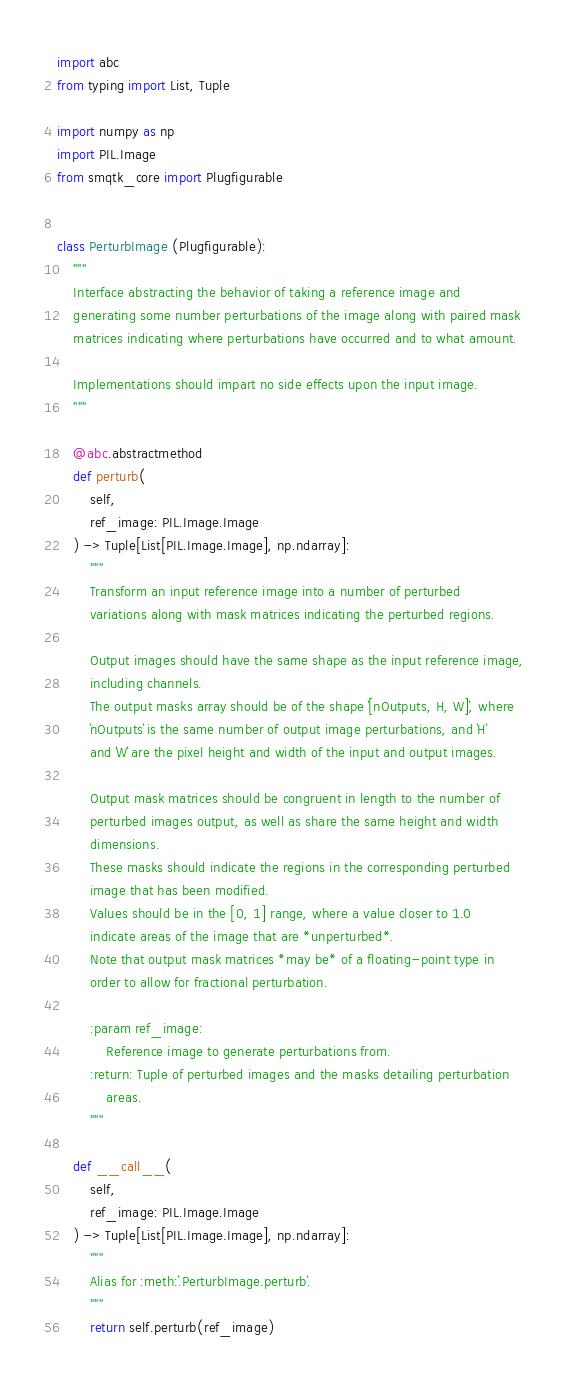<code> <loc_0><loc_0><loc_500><loc_500><_Python_>import abc
from typing import List, Tuple

import numpy as np
import PIL.Image
from smqtk_core import Plugfigurable


class PerturbImage (Plugfigurable):
    """
    Interface abstracting the behavior of taking a reference image and
    generating some number perturbations of the image along with paired mask
    matrices indicating where perturbations have occurred and to what amount.

    Implementations should impart no side effects upon the input image.
    """

    @abc.abstractmethod
    def perturb(
        self,
        ref_image: PIL.Image.Image
    ) -> Tuple[List[PIL.Image.Image], np.ndarray]:
        """
        Transform an input reference image into a number of perturbed
        variations along with mask matrices indicating the perturbed regions.

        Output images should have the same shape as the input reference image,
        including channels.
        The output masks array should be of the shape `[nOutputs, H, W]`, where
        `nOutputs` is the same number of output image perturbations, and `H`
        and `W` are the pixel height and width of the input and output images.

        Output mask matrices should be congruent in length to the number of
        perturbed images output, as well as share the same height and width
        dimensions.
        These masks should indicate the regions in the corresponding perturbed
        image that has been modified.
        Values should be in the [0, 1] range, where a value closer to 1.0
        indicate areas of the image that are *unperturbed*.
        Note that output mask matrices *may be* of a floating-point type in
        order to allow for fractional perturbation.

        :param ref_image:
            Reference image to generate perturbations from.
        :return: Tuple of perturbed images and the masks detailing perturbation
            areas.
        """

    def __call__(
        self,
        ref_image: PIL.Image.Image
    ) -> Tuple[List[PIL.Image.Image], np.ndarray]:
        """
        Alias for :meth:`.PerturbImage.perturb`.
        """
        return self.perturb(ref_image)
</code> 